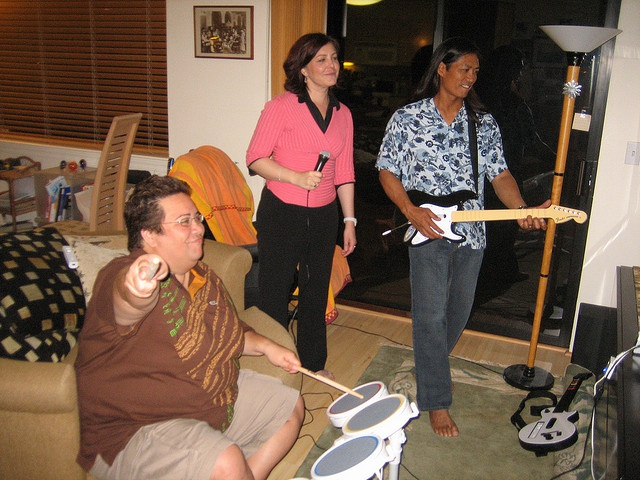Describe the objects in this image and their specific colors. I can see people in maroon, tan, and brown tones, people in maroon, black, gray, darkgray, and brown tones, people in maroon, black, salmon, and brown tones, chair in maroon, gray, tan, olive, and brown tones, and chair in maroon, red, orange, and black tones in this image. 